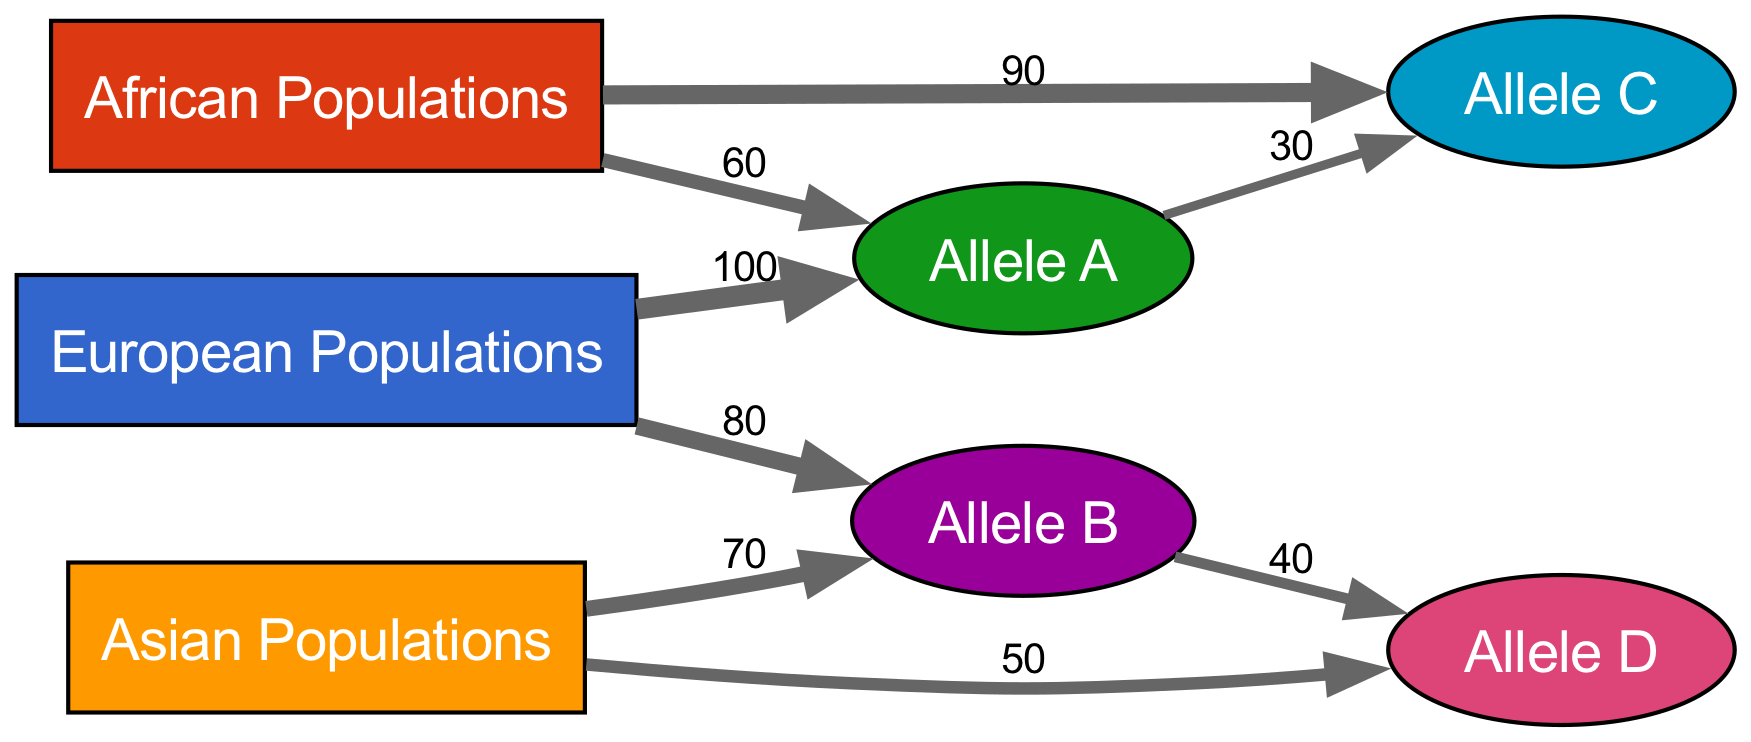What is the total number of populations represented in the diagram? The nodes section lists three population types: European, African, and Asian, which can be counted directly from the diagram's nodes.
Answer: 3 How many alleles are present in the diagram? The nodes section lists four alleles: Allele A, Allele B, Allele C, and Allele D, which can also be counted directly from the nodes.
Answer: 4 Which population has the highest flow to an allele? Looking through the links, we see European Populations have a flow of 100 to Allele A, which is the highest value compared to other flows.
Answer: European Populations What is the flow from African Populations to Allele C? The link from African Populations to Allele C indicates a flow of 90, which is shown by the value attached to that link.
Answer: 90 How many alleles are influenced by Allele A? Checking the links, Allele A has outgoing flows to Allele C with a value of 30, indicating it influences one allele.
Answer: 1 Which allele is the most common among Asian populations? From the links, Asian Populations has a flow of 70 to Allele B, which is the highest for that population in comparison to its flow to Allele D.
Answer: Allele B What is the total flow of Allele B to Allele D? The flow from Allele B to Allele D is indicated by a value of 40. Since there are no other links for this flow, we can observe the value directly.
Answer: 40 Which allele has the lowest total flow from populations? Observing the flows, Allele D has a total incoming flow of 50 from Asian populations, and 40 from Allele B, making a total of 90 flows compared to other alleles that have higher values.
Answer: Allele D Which population has the least overall influence on the alleles? Looking at the flows, African Populations has two flows (totaling 150), while Asian (120) and European (180) have more influence, making African Populations the least influential.
Answer: African Populations 